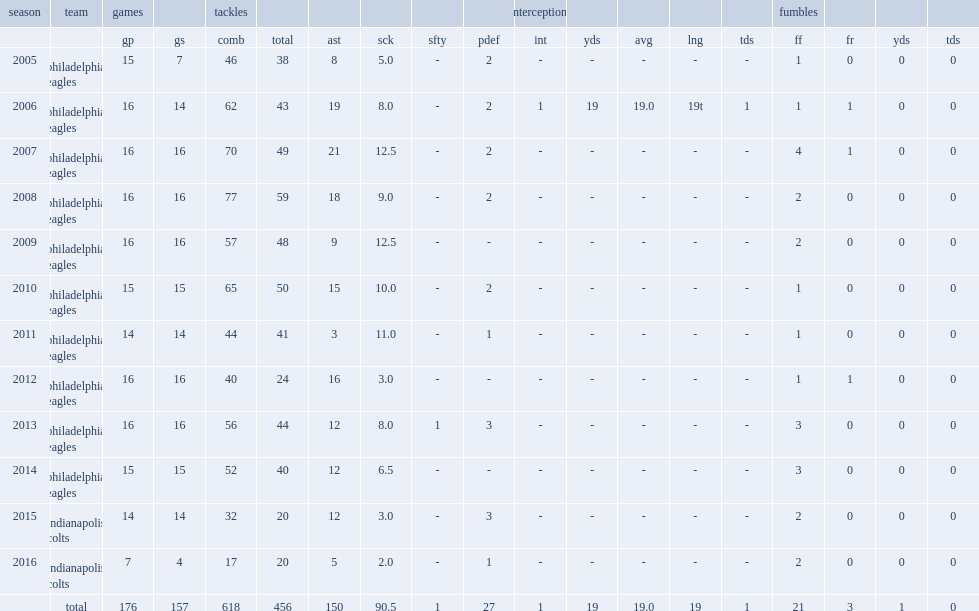How many sacks did cole make in the 2007 season? 12.5. 